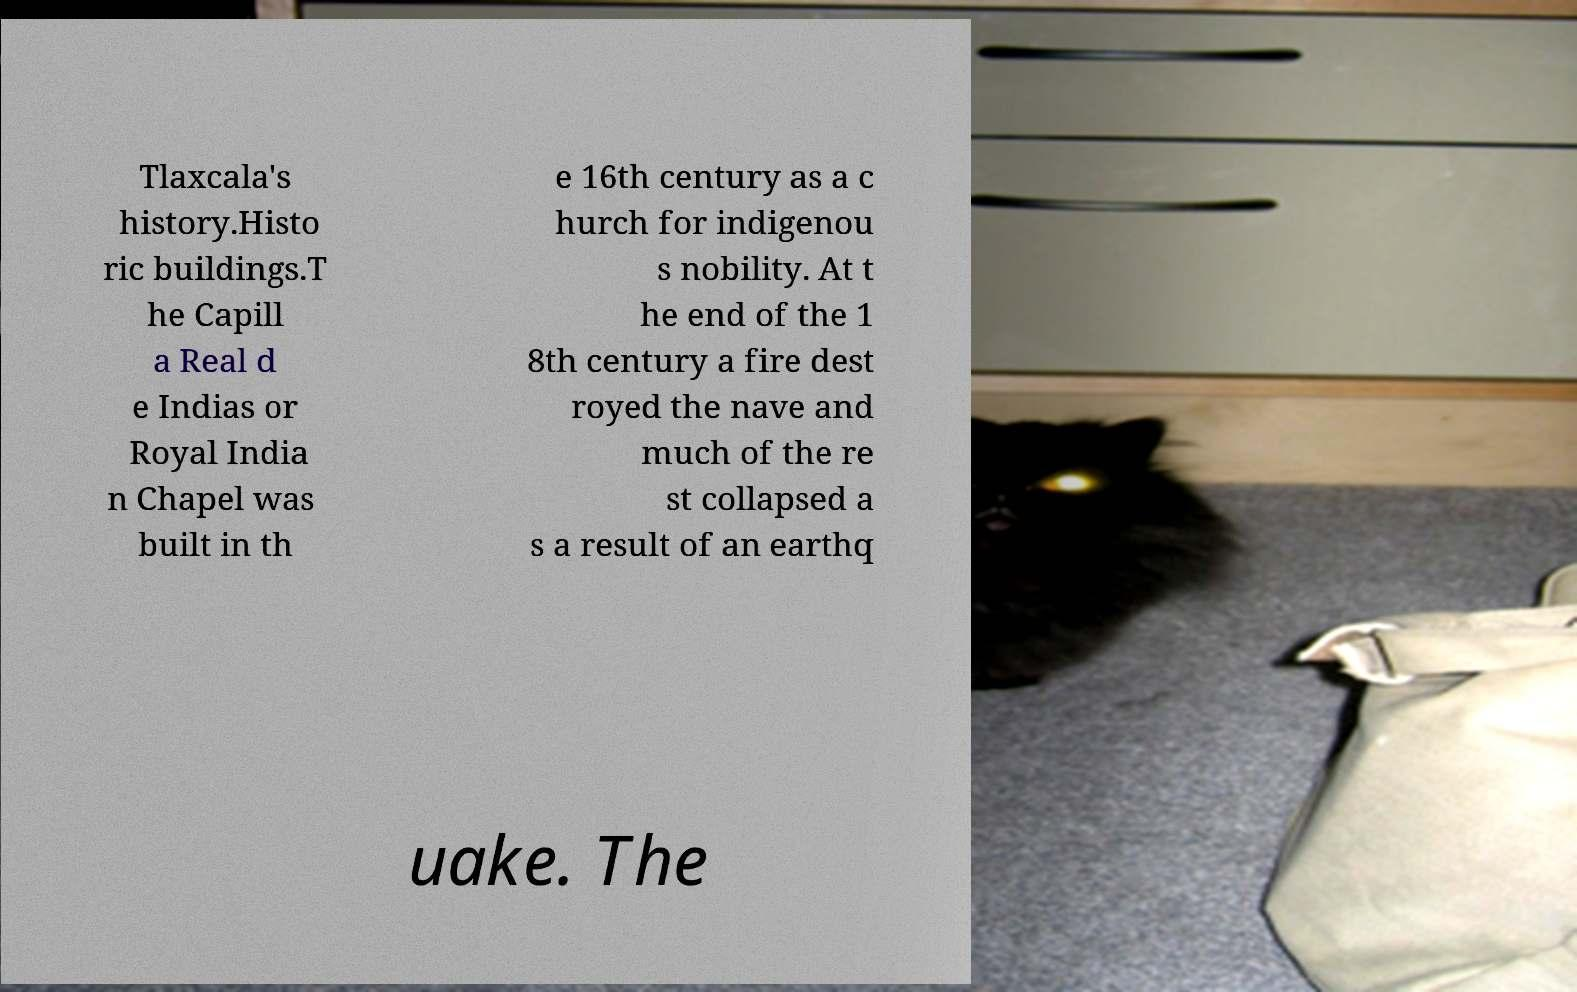Please read and relay the text visible in this image. What does it say? Tlaxcala's history.Histo ric buildings.T he Capill a Real d e Indias or Royal India n Chapel was built in th e 16th century as a c hurch for indigenou s nobility. At t he end of the 1 8th century a fire dest royed the nave and much of the re st collapsed a s a result of an earthq uake. The 